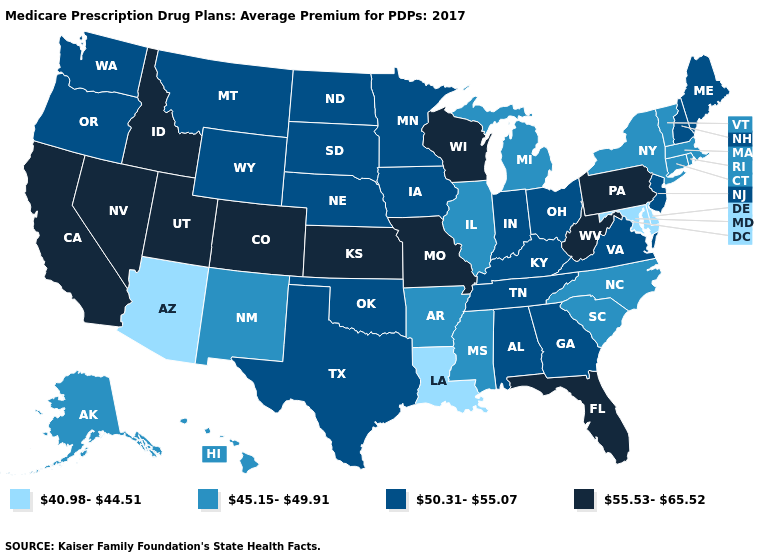Which states hav the highest value in the West?
Answer briefly. California, Colorado, Idaho, Nevada, Utah. What is the value of New York?
Give a very brief answer. 45.15-49.91. Name the states that have a value in the range 40.98-44.51?
Keep it brief. Arizona, Delaware, Louisiana, Maryland. Name the states that have a value in the range 45.15-49.91?
Give a very brief answer. Alaska, Arkansas, Connecticut, Hawaii, Illinois, Massachusetts, Michigan, Mississippi, North Carolina, New Mexico, New York, Rhode Island, South Carolina, Vermont. Does Louisiana have a lower value than Delaware?
Quick response, please. No. Does Iowa have the highest value in the MidWest?
Concise answer only. No. Name the states that have a value in the range 55.53-65.52?
Write a very short answer. California, Colorado, Florida, Idaho, Kansas, Missouri, Nevada, Pennsylvania, Utah, Wisconsin, West Virginia. Which states have the lowest value in the South?
Concise answer only. Delaware, Louisiana, Maryland. Name the states that have a value in the range 40.98-44.51?
Quick response, please. Arizona, Delaware, Louisiana, Maryland. Does Oregon have the same value as Illinois?
Short answer required. No. How many symbols are there in the legend?
Be succinct. 4. What is the lowest value in states that border Kentucky?
Keep it brief. 45.15-49.91. Name the states that have a value in the range 45.15-49.91?
Write a very short answer. Alaska, Arkansas, Connecticut, Hawaii, Illinois, Massachusetts, Michigan, Mississippi, North Carolina, New Mexico, New York, Rhode Island, South Carolina, Vermont. Among the states that border Massachusetts , which have the lowest value?
Give a very brief answer. Connecticut, New York, Rhode Island, Vermont. 